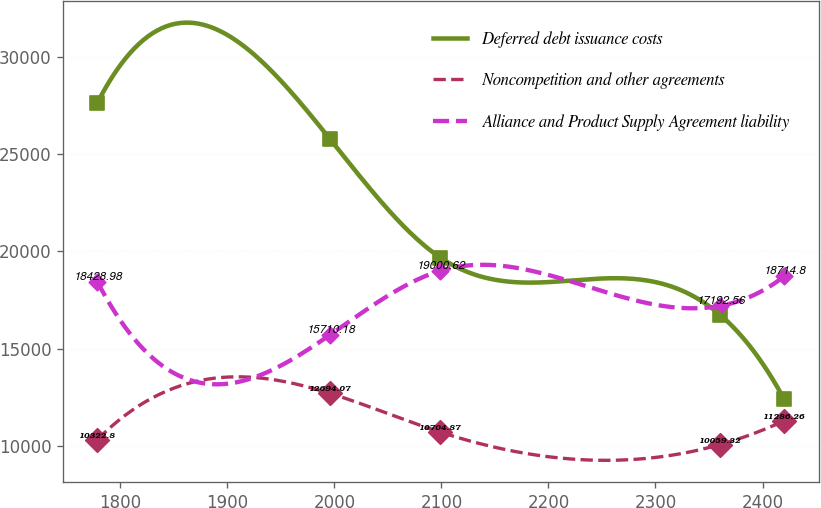<chart> <loc_0><loc_0><loc_500><loc_500><line_chart><ecel><fcel>Deferred debt issuance costs<fcel>Noncompetition and other agreements<fcel>Alliance and Product Supply Agreement liability<nl><fcel>1778.75<fcel>27642.9<fcel>10322.8<fcel>18429<nl><fcel>1996.15<fcel>25758.7<fcel>12694.1<fcel>15710.2<nl><fcel>2098.97<fcel>19678.5<fcel>10704.9<fcel>19000.6<nl><fcel>2360.1<fcel>16748.2<fcel>10059.3<fcel>17192.6<nl><fcel>2420.2<fcel>12393.7<fcel>11286.3<fcel>18714.8<nl></chart> 